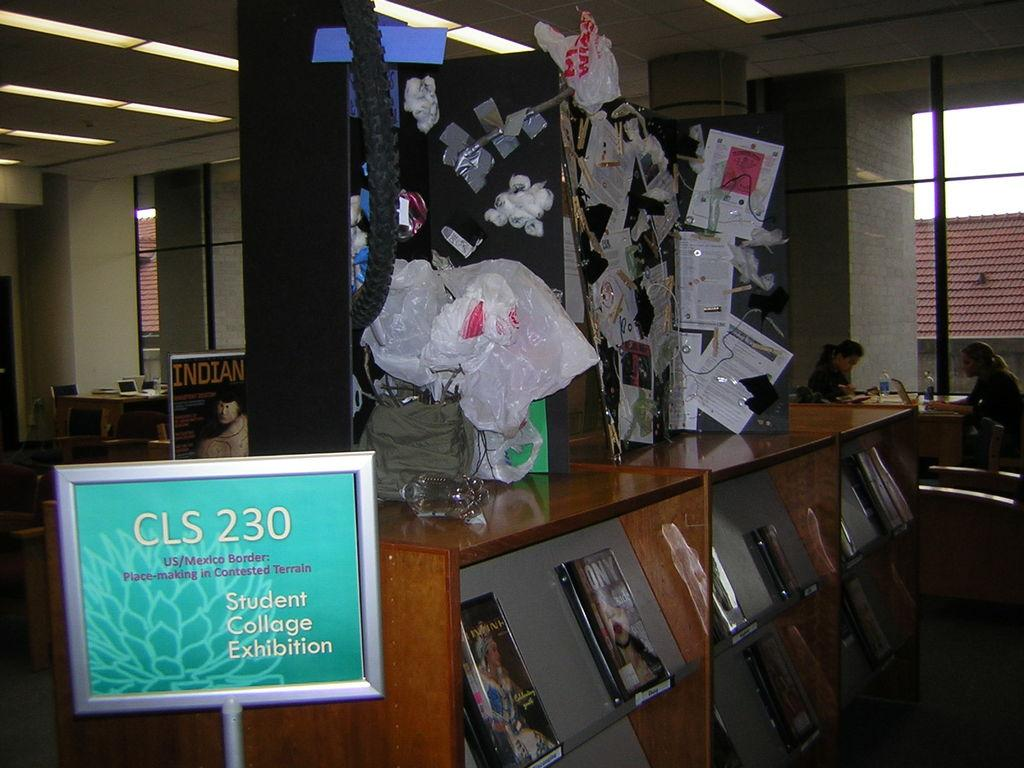What is the color of the board in the image? The board in the image is green-colored. What items related to reading or writing can be seen in the image? There are books, papers, and covers visible in the image. Can you describe the people in the background of the image? There are two persons sitting in the background of the image. What type of architectural feature is present in the background? There are glass walls in the background. What type of knife is being used to sharpen the chalk in the image? There is no knife or chalk present in the image. Who is the servant attending to in the image? There is no servant present in the image. 